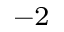<formula> <loc_0><loc_0><loc_500><loc_500>^ { - 2 }</formula> 